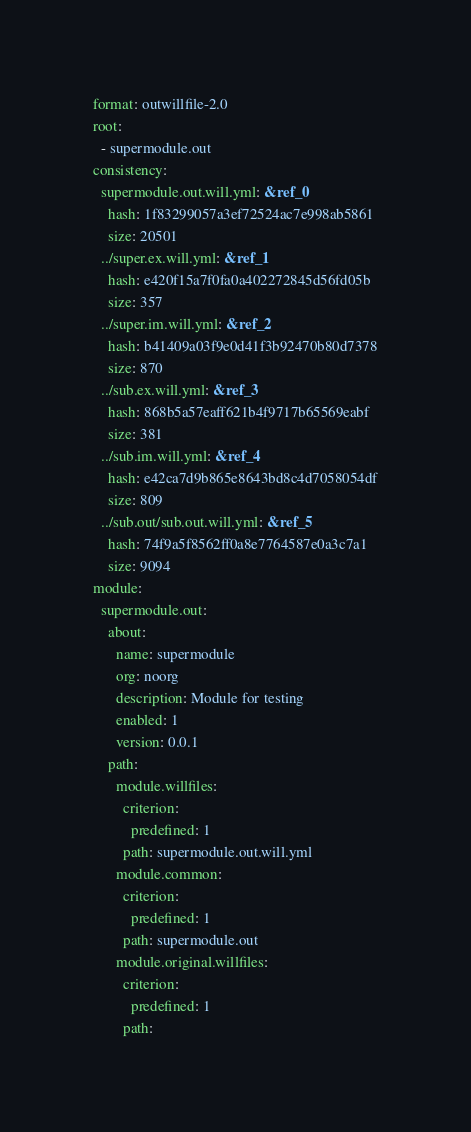<code> <loc_0><loc_0><loc_500><loc_500><_YAML_>format: outwillfile-2.0
root:
  - supermodule.out
consistency:
  supermodule.out.will.yml: &ref_0
    hash: 1f83299057a3ef72524ac7e998ab5861
    size: 20501
  ../super.ex.will.yml: &ref_1
    hash: e420f15a7f0fa0a402272845d56fd05b
    size: 357
  ../super.im.will.yml: &ref_2
    hash: b41409a03f9e0d41f3b92470b80d7378
    size: 870
  ../sub.ex.will.yml: &ref_3
    hash: 868b5a57eaff621b4f9717b65569eabf
    size: 381
  ../sub.im.will.yml: &ref_4
    hash: e42ca7d9b865e8643bd8c4d7058054df
    size: 809
  ../sub.out/sub.out.will.yml: &ref_5
    hash: 74f9a5f8562ff0a8e7764587e0a3c7a1
    size: 9094
module:
  supermodule.out:
    about:
      name: supermodule
      org: noorg
      description: Module for testing
      enabled: 1
      version: 0.0.1
    path:
      module.willfiles:
        criterion:
          predefined: 1
        path: supermodule.out.will.yml
      module.common:
        criterion:
          predefined: 1
        path: supermodule.out
      module.original.willfiles:
        criterion:
          predefined: 1
        path:</code> 